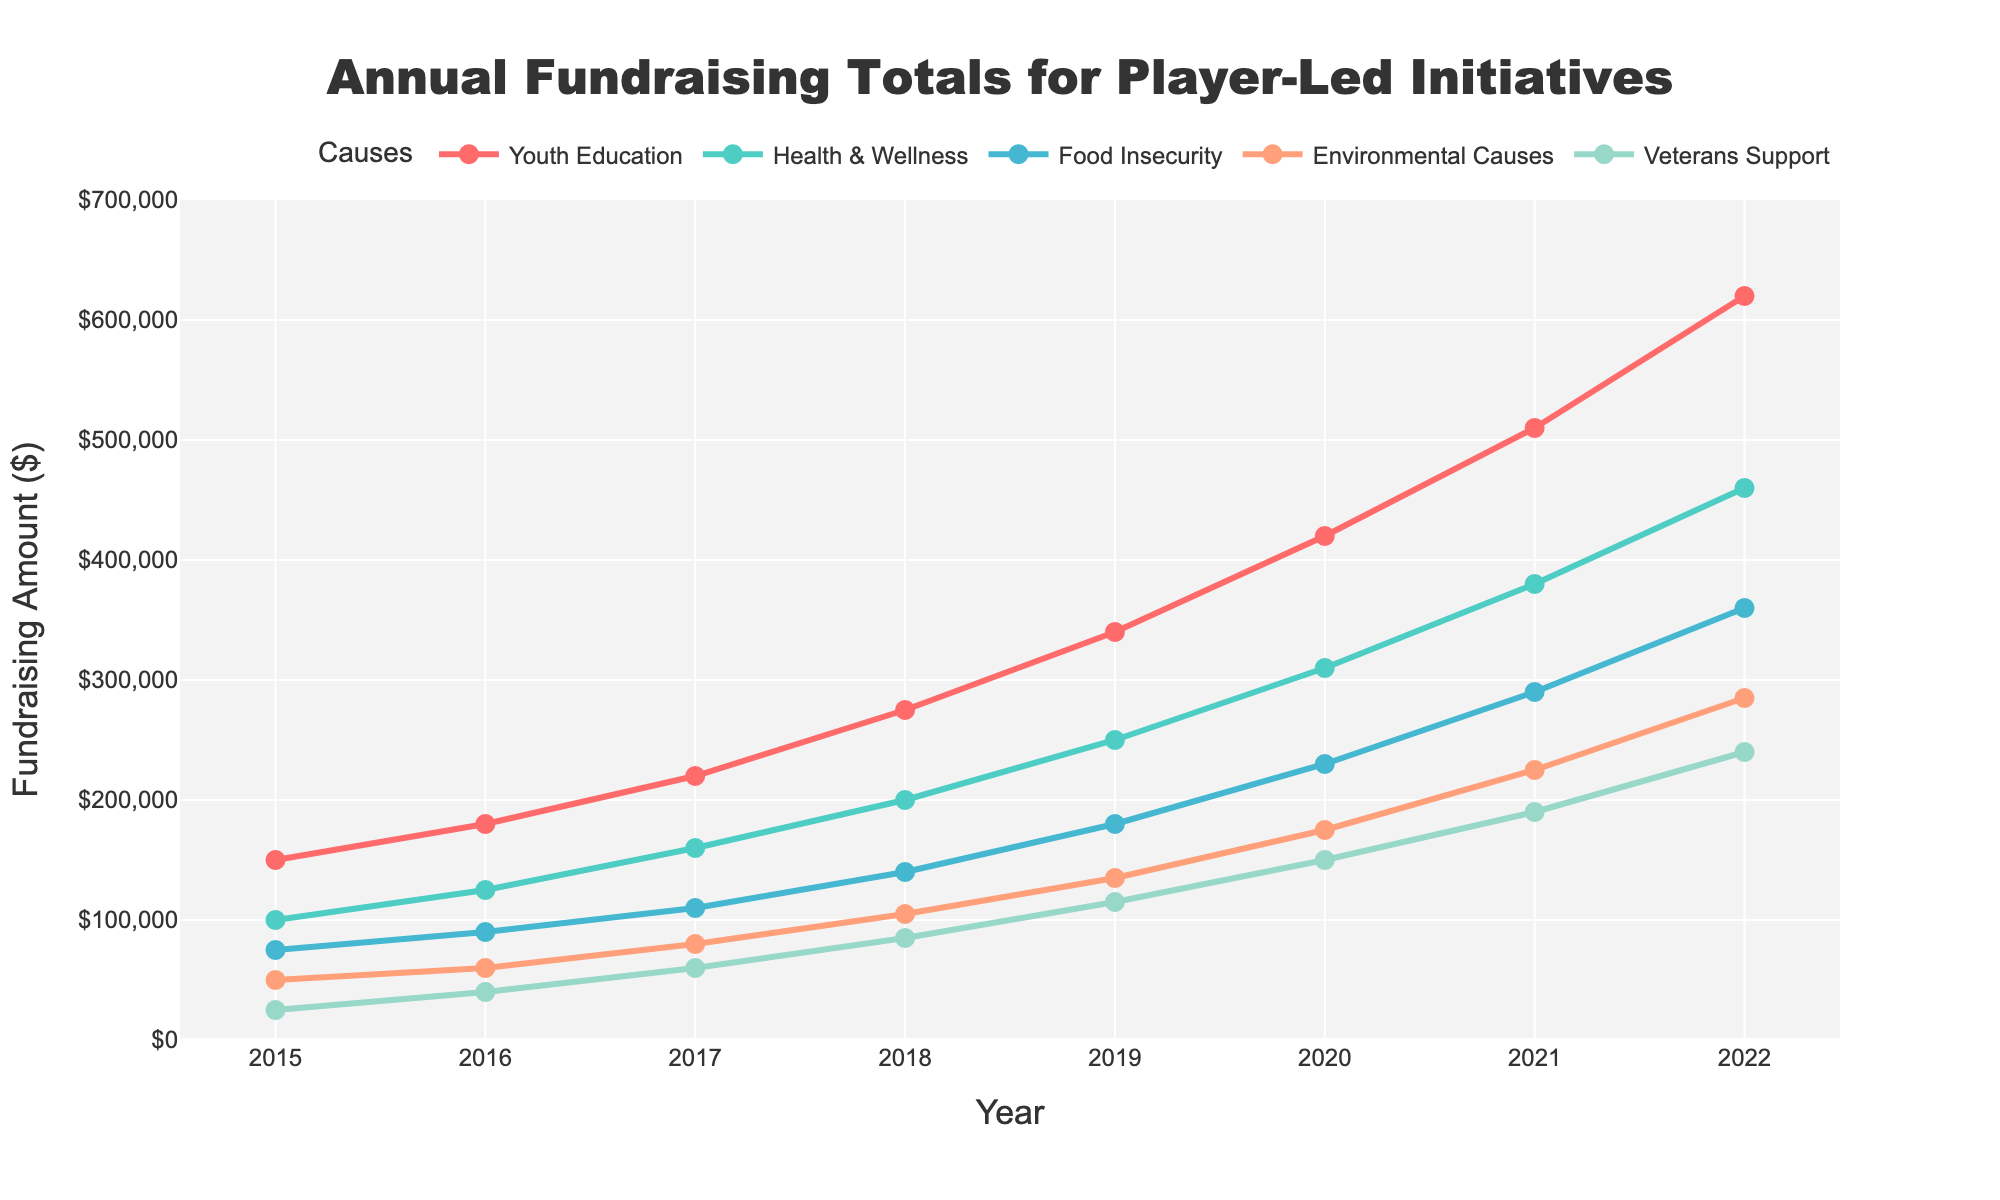What is the total fundraising amount for Youth Education and Health & Wellness in 2022? First, locate the fundraising amounts for Youth Education and Health & Wellness in 2022, which are $620,000 and $460,000, respectively. Then, add these amounts together: $620,000 + $460,000 = $1,080,000.
Answer: $1,080,000 Which cause had the highest fundraising amount in 2020? To determine which cause had the highest fundraising amount in 2020, compare the fundraising amounts for all causes in that year: Youth Education ($420,000), Health & Wellness ($310,000), Food Insecurity ($230,000), Environmental Causes ($175,000), and Veterans Support ($150,000). Youth Education has the highest amount.
Answer: Youth Education What is the difference in fundraising between Health & Wellness and Food Insecurity in 2019? Locate the 2019 fundraising numbers for Health & Wellness and Food Insecurity, which are $250,000 and $180,000, respectively. Subtract the amount for Food Insecurity from Health & Wellness: $250,000 - $180,000 = $70,000.
Answer: $70,000 Which year saw the most significant growth in fundraising for Environmental Causes? Compare the annual fundraising amounts for Environmental Causes across all years: $50,000 (2015), $60,000 (2016), $80,000 (2017), $105,000 (2018), $135,000 (2019), $175,000 (2020), $225,000 (2021), and $285,000 (2022). The year with the most significant increase is 2019 to 2020, with an increase of $40,000 ($175,000 - $135,000).
Answer: 2020 What is the average annual fundraising amount for Veterans Support from 2015 to 2020? Add the annual fundraising amounts for Veterans Support from 2015 to 2020: $25,000 (2015) + $40,000 (2016) + $60,000 (2017) + $85,000 (2018) + $115,000 (2019) + $150,000 (2020) = $475,000. Then, divide by the number of years (6): $475,000 / 6 = $79,167.
Answer: $79,167 In which year did Food Insecurity surpass 200,000 in fundraising for the first time? Examine the annual fundraising totals for Food Insecurity: $75,000 (2015), $90,000 (2016), $110,000 (2017), $140,000 (2018), $180,000 (2019), $230,000 (2020), $290,000 (2021), $360,000 (2022). Food Insecurity surpassed $200,000 for the first time in 2020.
Answer: 2020 How much more did Youth Education raise compared to Veterans Support in 2017? Locate the fundraising amounts for Youth Education and Veterans Support in 2017, which are $220,000 and $60,000, respectively. Subtract the Veterans Support amount from the Youth Education amount: $220,000 - $60,000 = $160,000.
Answer: $160,000 What is the trend in fundraising for Health & Wellness from 2015 to 2022? Analyze the fundraising amounts for Health & Wellness over the years: $100,000 (2015), $125,000 (2016), $160,000 (2017), $200,000 (2018), $250,000 (2019), $310,000 (2020), $380,000 (2021), and $460,000 (2022). The trend is a steady increase each year.
Answer: Steady increase 